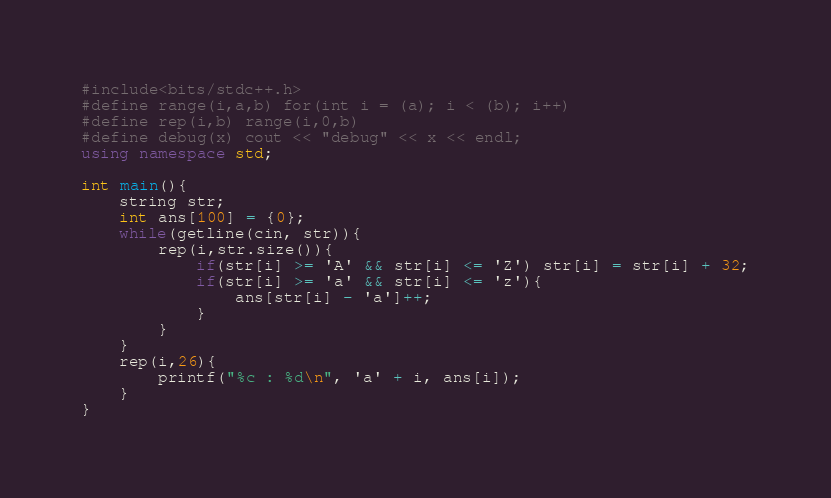Convert code to text. <code><loc_0><loc_0><loc_500><loc_500><_C++_>#include<bits/stdc++.h>
#define range(i,a,b) for(int i = (a); i < (b); i++)
#define rep(i,b) range(i,0,b)
#define debug(x) cout << "debug" << x << endl;
using namespace std;

int main(){
    string str;
    int ans[100] = {0};
    while(getline(cin, str)){
        rep(i,str.size()){
            if(str[i] >= 'A' && str[i] <= 'Z') str[i] = str[i] + 32;
            if(str[i] >= 'a' && str[i] <= 'z'){
                ans[str[i] - 'a']++;
            }
        }
    }
    rep(i,26){
        printf("%c : %d\n", 'a' + i, ans[i]);
    }
}</code> 